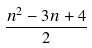<formula> <loc_0><loc_0><loc_500><loc_500>\frac { n ^ { 2 } - 3 n + 4 } { 2 }</formula> 